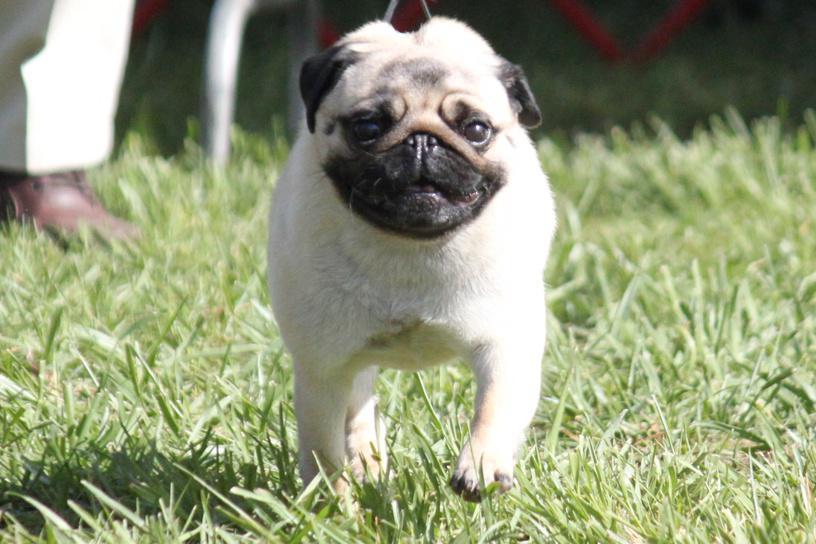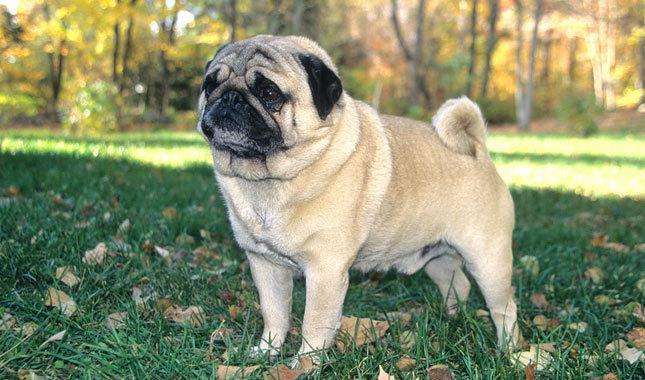The first image is the image on the left, the second image is the image on the right. For the images shown, is this caption "The lighter colored dog is sitting in the grass." true? Answer yes or no. No. 